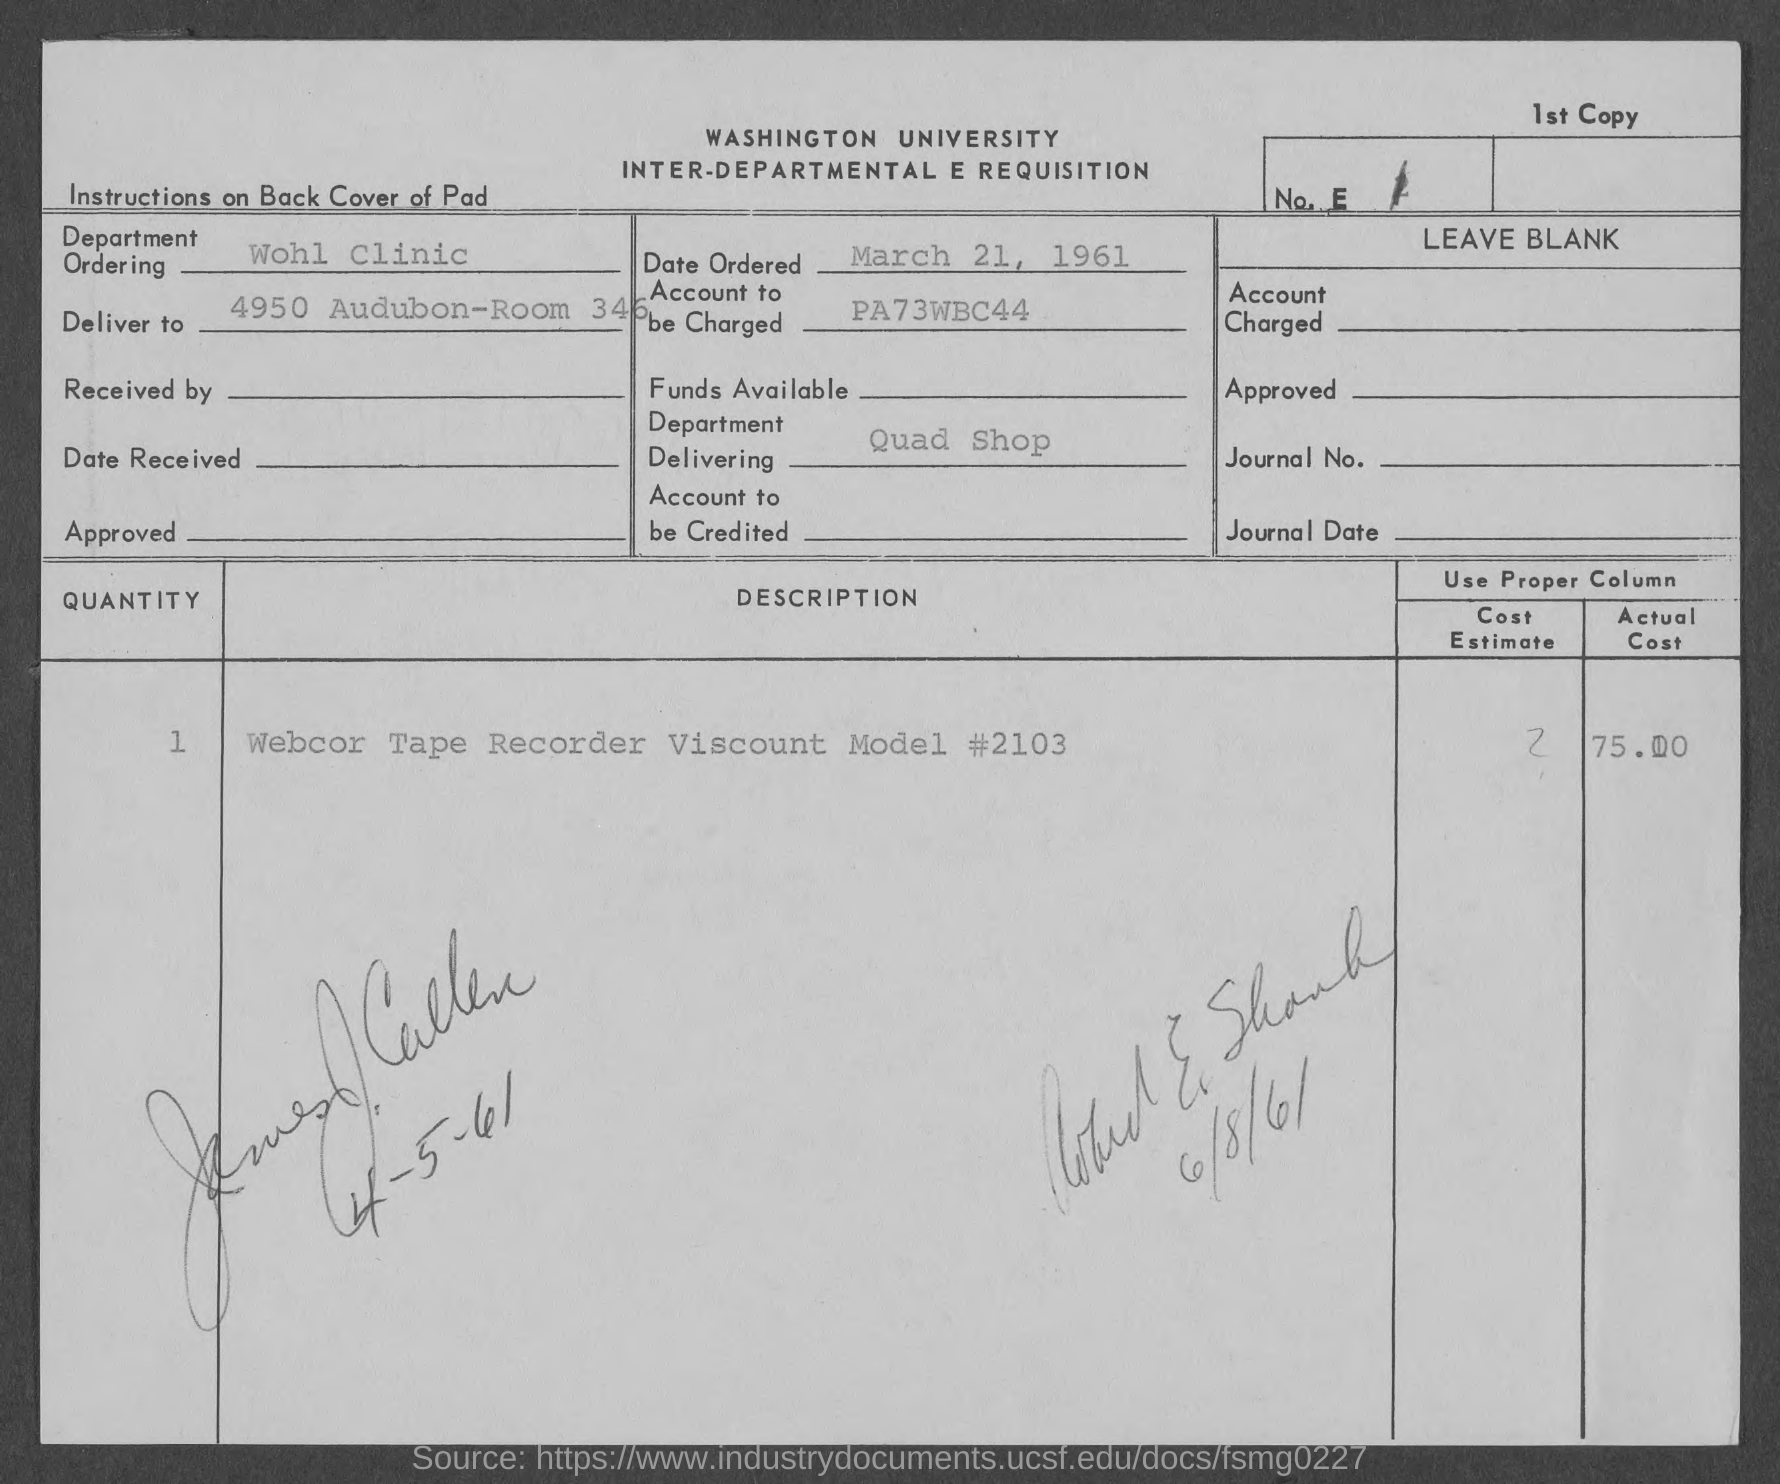What is the date of ordered ?
Offer a terse response. March 21, 1961. What is the account to be charged as mentioned in the given page ?
Your response must be concise. PA73WBC44. What is the name of the department ordering as mentioned in the given page ?
Keep it short and to the point. Wohl clinic. What is the name of the department delivering as mentioned in the given page ?
Offer a very short reply. Quad shop. What is the quantity mentioned in the given page  ?
Provide a short and direct response. 1. 